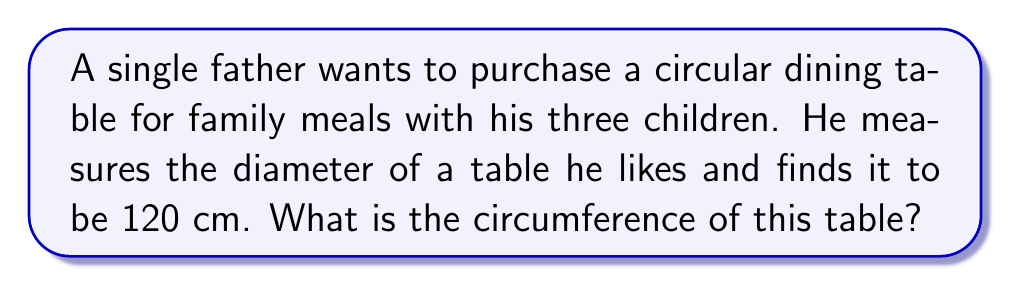Give your solution to this math problem. To solve this problem, we'll follow these steps:

1) Recall the formula for the circumference of a circle:
   $$C = \pi d$$
   where $C$ is the circumference, $\pi$ is pi (approximately 3.14159), and $d$ is the diameter.

2) We're given the diameter $d = 120$ cm.

3) Substitute this value into the formula:
   $$C = \pi \cdot 120$$

4) Calculate:
   $$C \approx 3.14159 \cdot 120 \approx 376.99 \text{ cm}$$

5) Round to the nearest centimeter:
   $$C \approx 377 \text{ cm}$$

This circumference provides enough space for the father and his three children to comfortably sit around the table for family meals.

[asy]
import geometry;

size(200);
pair O = (0,0);
real r = 3;
draw(circle(O,r));
draw((-r,0)--(r,0),dashed);
label("120 cm",(-r,0),S);
label("Circumference ≈ 377 cm",(-r,-r-0.5),S);
[/asy]
Answer: $377 \text{ cm}$ 